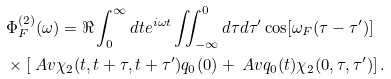Convert formula to latex. <formula><loc_0><loc_0><loc_500><loc_500>& \Phi _ { F } ^ { ( 2 ) } ( \omega ) = \Re \int _ { 0 } ^ { \infty } d t e ^ { i \omega t } \iint _ { - \infty } ^ { 0 } d \tau d \tau ^ { \prime } \cos [ \omega _ { F } ( \tau - \tau ^ { \prime } ) ] \\ & \times \left [ \ A v { \chi _ { 2 } ( t , t + \tau , t + \tau ^ { \prime } ) q _ { 0 } ( 0 ) } + \ A v { q _ { 0 } ( t ) \chi _ { 2 } ( 0 , \tau , \tau ^ { \prime } ) } \right ] .</formula> 